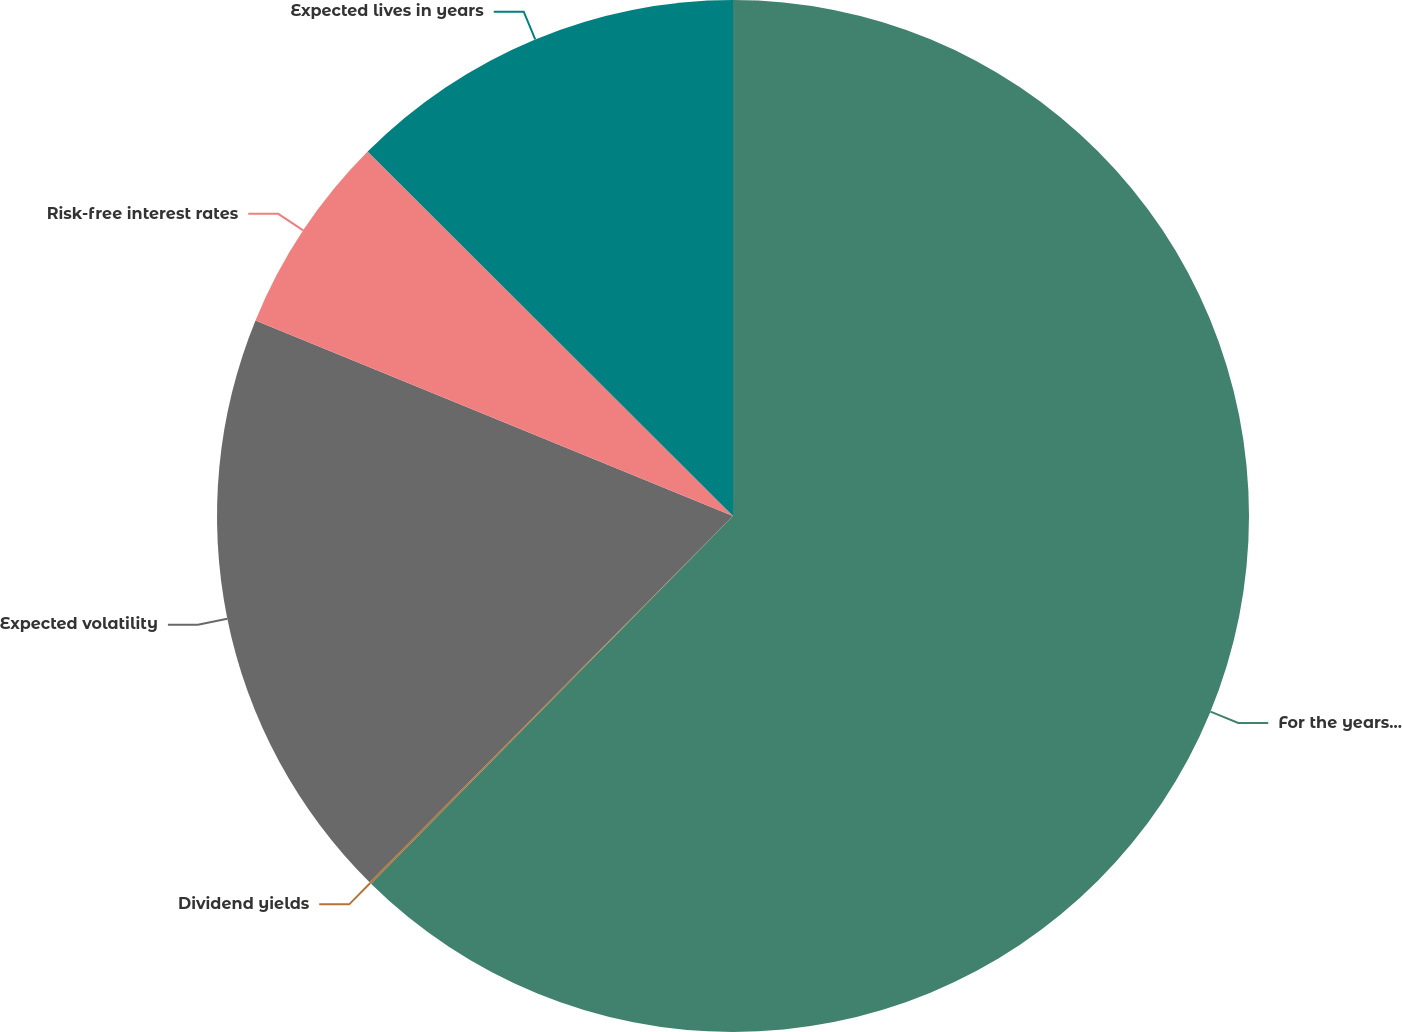Convert chart to OTSL. <chart><loc_0><loc_0><loc_500><loc_500><pie_chart><fcel>For the years ended December<fcel>Dividend yields<fcel>Expected volatility<fcel>Risk-free interest rates<fcel>Expected lives in years<nl><fcel>62.37%<fcel>0.06%<fcel>18.75%<fcel>6.29%<fcel>12.52%<nl></chart> 